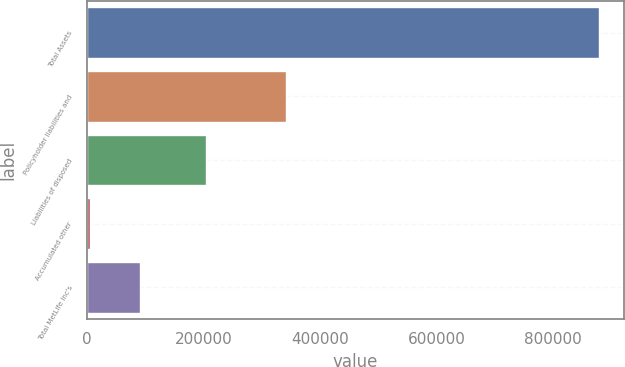<chart> <loc_0><loc_0><loc_500><loc_500><bar_chart><fcel>Total Assets<fcel>Policyholder liabilities and<fcel>Liabilities of disposed<fcel>Accumulated other<fcel>Total MetLife Inc's<nl><fcel>877912<fcel>342047<fcel>204314<fcel>4767<fcel>92081.5<nl></chart> 